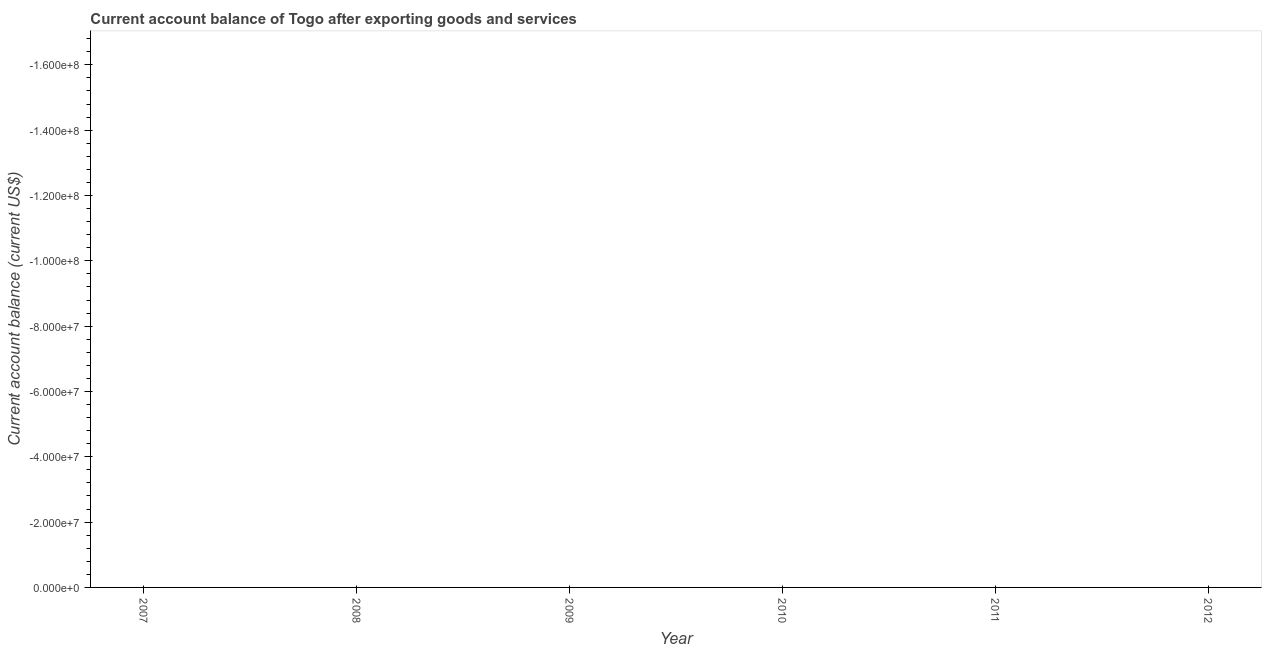What is the current account balance in 2009?
Keep it short and to the point. 0. What is the median current account balance?
Your answer should be very brief. 0. In how many years, is the current account balance greater than the average current account balance taken over all years?
Keep it short and to the point. 0. Does the current account balance monotonically increase over the years?
Provide a short and direct response. No. How many lines are there?
Give a very brief answer. 0. What is the difference between two consecutive major ticks on the Y-axis?
Your answer should be compact. 2.00e+07. Does the graph contain grids?
Your answer should be compact. No. What is the title of the graph?
Your answer should be very brief. Current account balance of Togo after exporting goods and services. What is the label or title of the X-axis?
Offer a terse response. Year. What is the label or title of the Y-axis?
Provide a succinct answer. Current account balance (current US$). What is the Current account balance (current US$) of 2009?
Provide a succinct answer. 0. What is the Current account balance (current US$) in 2010?
Make the answer very short. 0. What is the Current account balance (current US$) in 2011?
Your answer should be compact. 0. 